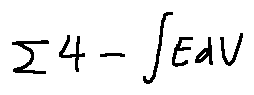Convert formula to latex. <formula><loc_0><loc_0><loc_500><loc_500>\sum 4 - \int E d V</formula> 